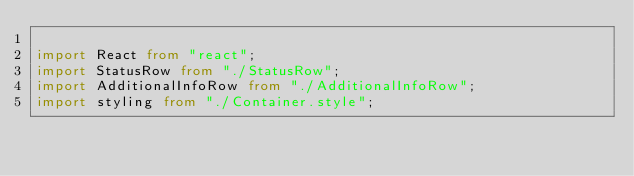Convert code to text. <code><loc_0><loc_0><loc_500><loc_500><_TypeScript_>
import React from "react";
import StatusRow from "./StatusRow";
import AdditionalInfoRow from "./AdditionalInfoRow";
import styling from "./Container.style";</code> 